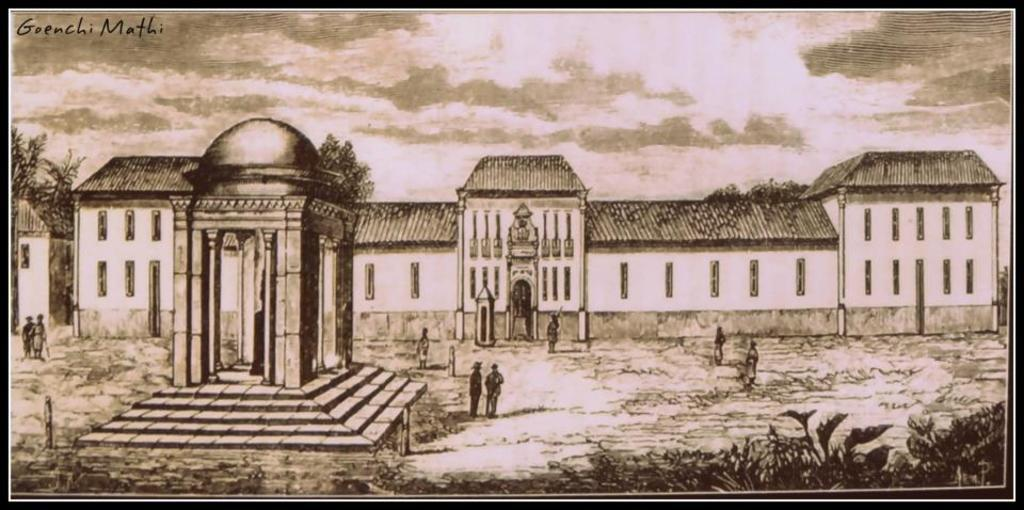What type of art is depicted in the image? There is art of people in the image. What else can be seen in the image besides the art? There are buildings, plants on the right side, and trees and clouds in the background. What is visible in the sky in the image? The sky is visible in the background of the image. What type of gold is being used to create the ink in the image? There is no mention of gold or ink in the image, as it features art of people, buildings, plants, trees, clouds, and the sky. 